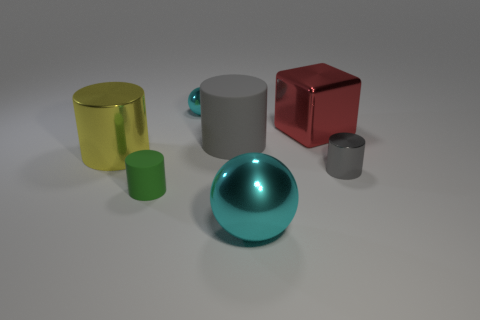Add 1 tiny yellow matte cylinders. How many objects exist? 8 Subtract all big metal cylinders. How many cylinders are left? 3 Subtract all cyan balls. How many gray cylinders are left? 2 Subtract all green cylinders. How many cylinders are left? 3 Subtract all balls. How many objects are left? 5 Subtract 0 gray cubes. How many objects are left? 7 Subtract all red balls. Subtract all cyan blocks. How many balls are left? 2 Subtract all tiny gray matte cubes. Subtract all gray metallic objects. How many objects are left? 6 Add 6 tiny cylinders. How many tiny cylinders are left? 8 Add 2 big red objects. How many big red objects exist? 3 